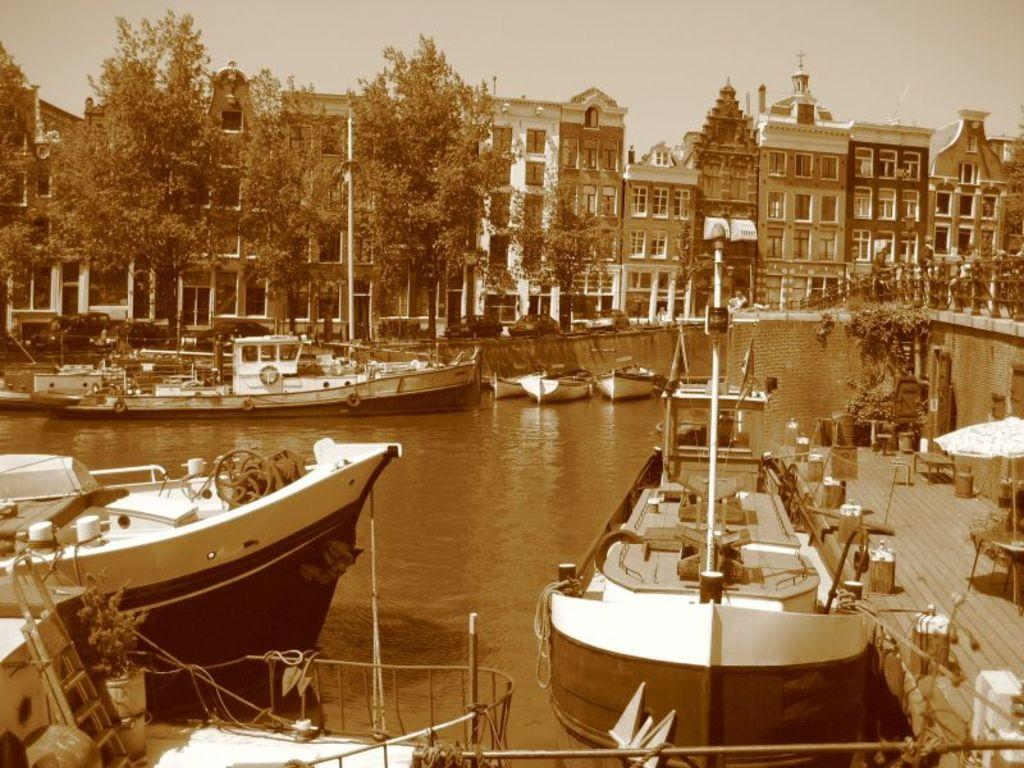What type of location is shown in the image? The image depicts a city. What can be seen on the water in the image? There are boats on the water in the image. What type of vegetation is present in the image? There are trees in the image. What type of structures are visible in the image? There are buildings in the image. What is visible in the background of the image? The sky is visible in the background of the image. What type of nose can be seen on the boats in the image? There are no noses present on the boats in the image; they are not human or animal figures. 